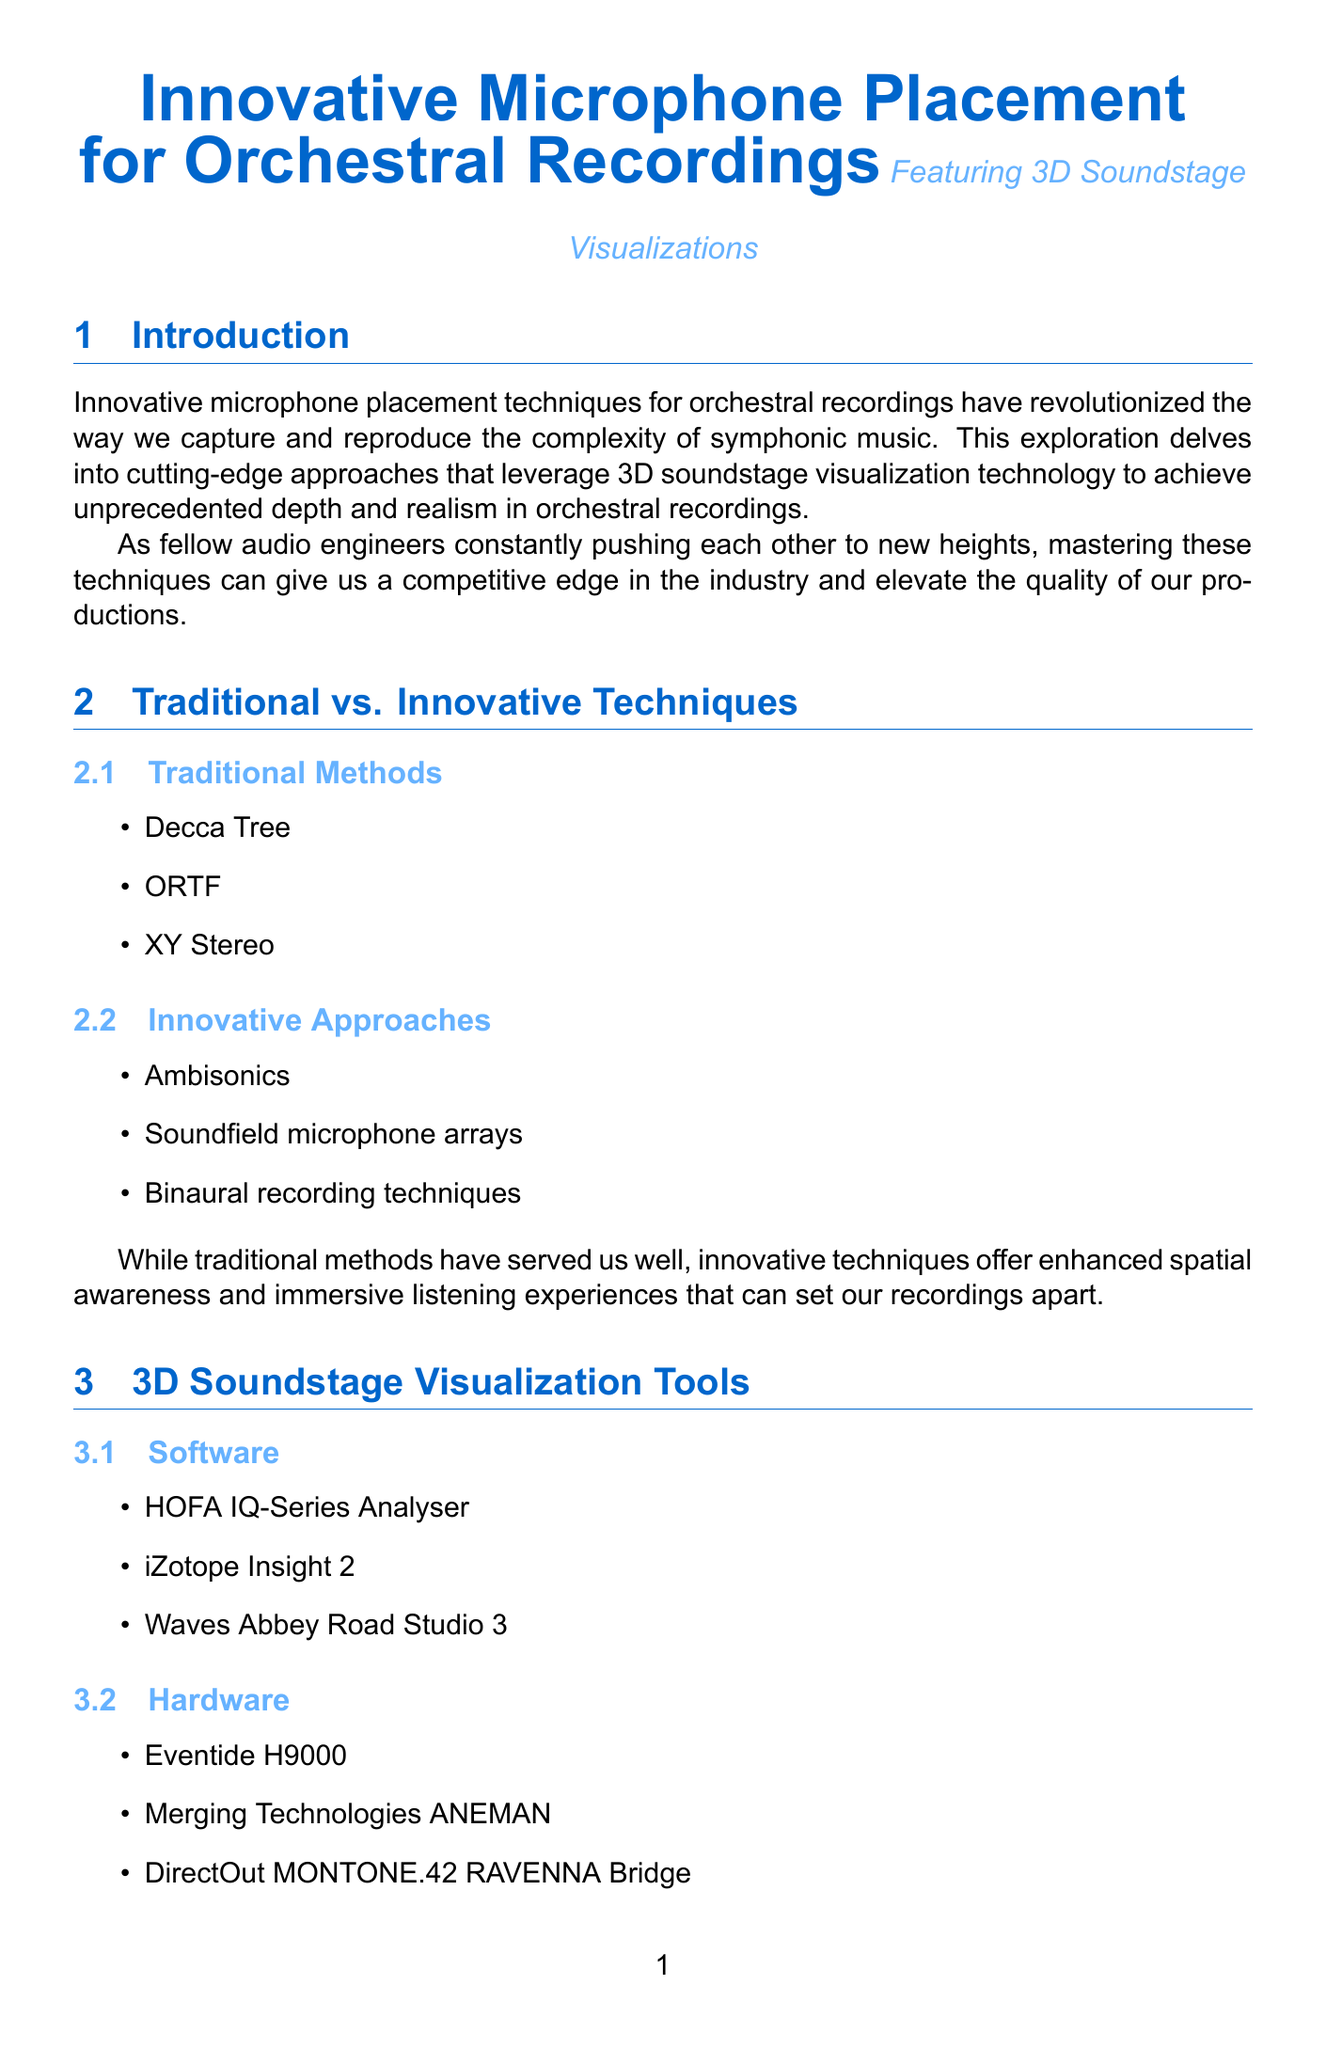What is the title of the report? The title of the report is stated prominently at the beginning of the document.
Answer: Innovative Microphone Placement for Orchestral Recordings What technique captures nuanced timbral details? This technique focuses on capturing details within each orchestral section using specific microphones.
Answer: Section-Specific Boundary Layer (SSBL) How many innovative microphone placement techniques are discussed? The document lists three innovative techniques in a dedicated section.
Answer: Three Which orchestra recorded Mahler's Symphony No. 2? The case study provides the names of the orchestras associated with specific recordings.
Answer: London Symphony Orchestra What software is used for 3D soundstage visualization? The document identifies several software tools for visual representation of the soundstage.
Answer: HOFA IQ-Series Analyser What is a key benefit of using innovative techniques? The comparison section highlights the advantages of innovative techniques over traditional ones.
Answer: Enhanced spatial awareness What is the placement height for Elevated Ambience Capture? The document specifies the height at which microphones are suspended for this technique.
Answer: 15-20 feet What is a potential future development mentioned? The document discusses possible advancements related to orchestral recording techniques.
Answer: AI-powered microphone placement optimization What challenge involves multiple microphone techniques? The challenges section outlines various issues faced when using different microphone placements.
Answer: Phase coherence issues 